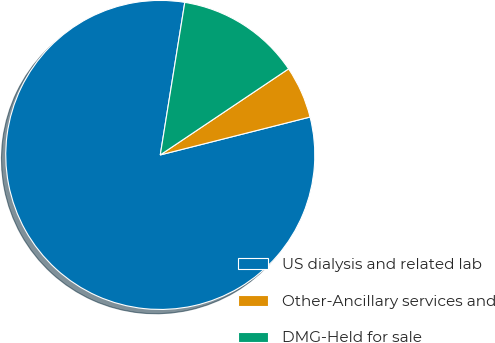Convert chart. <chart><loc_0><loc_0><loc_500><loc_500><pie_chart><fcel>US dialysis and related lab<fcel>Other-Ancillary services and<fcel>DMG-Held for sale<nl><fcel>81.48%<fcel>5.46%<fcel>13.06%<nl></chart> 